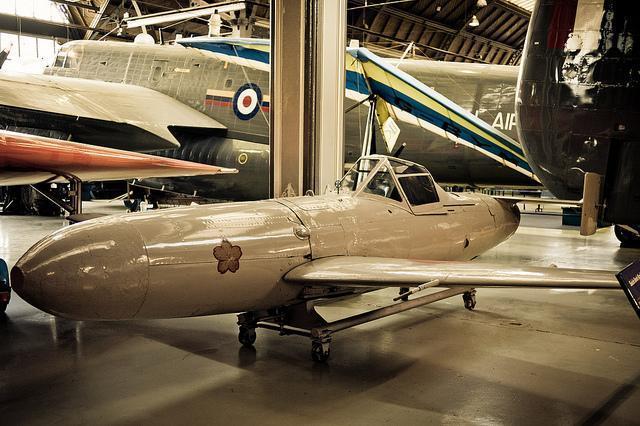How many airplanes are in the photo?
Give a very brief answer. 3. How many people are wearing black shirts?
Give a very brief answer. 0. 